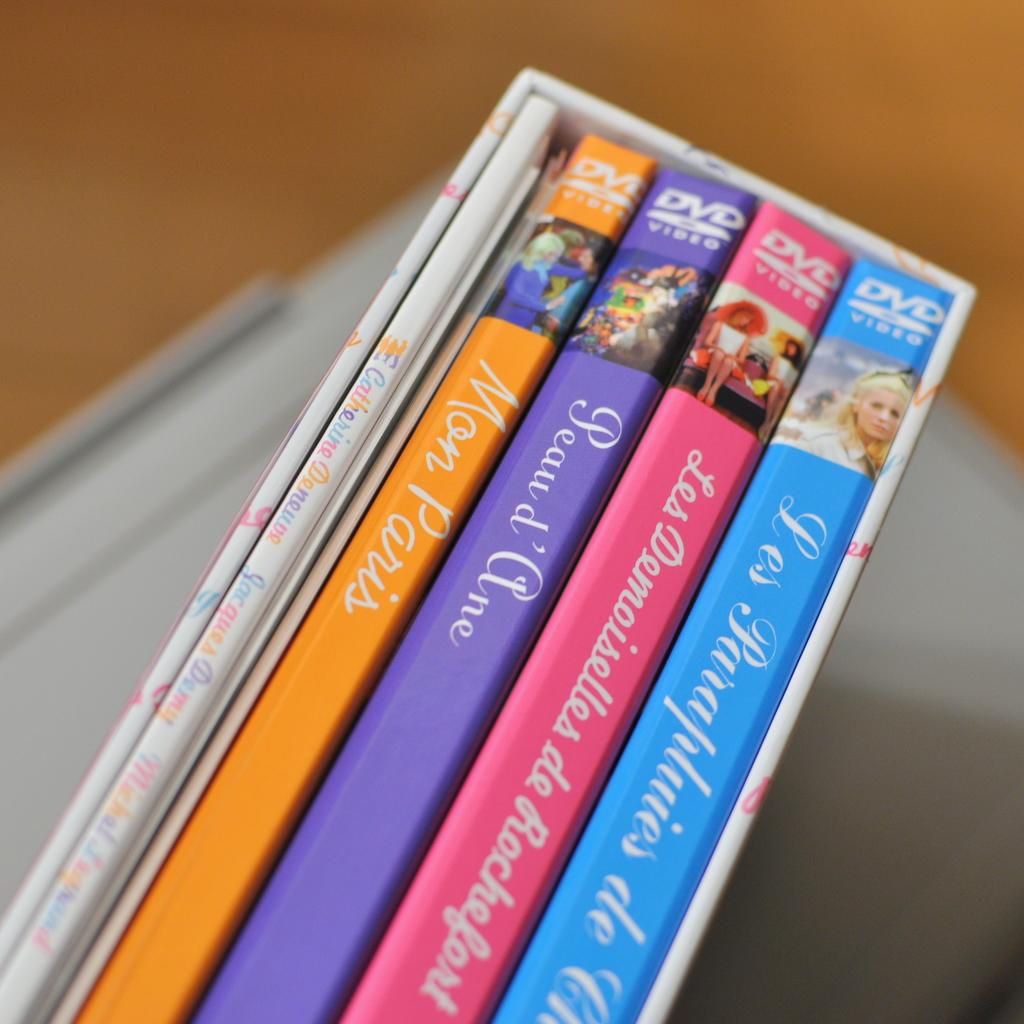<image>
Present a compact description of the photo's key features. Four DVD cases are held together in a wooden box along with a small booklet 